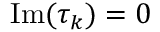Convert formula to latex. <formula><loc_0><loc_0><loc_500><loc_500>I m ( \tau _ { k } ) = 0</formula> 